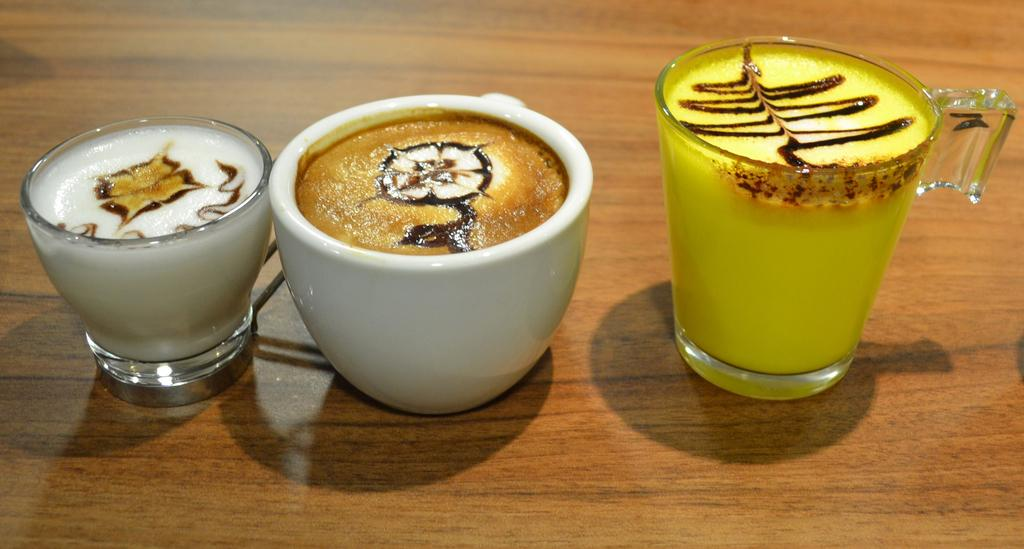What is the color of the surface in the image? The surface in the image is brown. How many glasses are on the brown surface? There are 2 glasses on the brown surface. What else is on the brown surface besides the glasses? There is a white cup on the brown surface. What is inside the white cup? The white cup contains liquid. Where is the silk pillow located in the image? There is no silk pillow present in the image. What type of animals can be seen on the farm in the image? There is no farm or animals present in the image. 